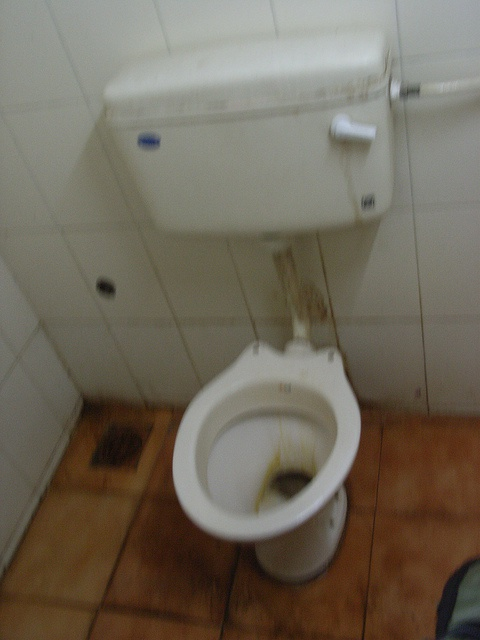Describe the objects in this image and their specific colors. I can see a toilet in gray, darkgray, and darkgreen tones in this image. 